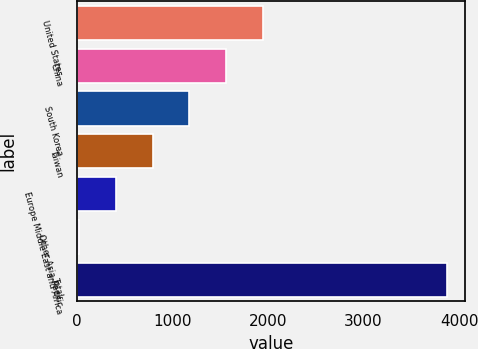<chart> <loc_0><loc_0><loc_500><loc_500><bar_chart><fcel>United States<fcel>China<fcel>South Korea<fcel>Taiwan<fcel>Europe Middle East and Africa<fcel>Other Asia-Pacific<fcel>Total<nl><fcel>1946.2<fcel>1560.76<fcel>1176.22<fcel>791.68<fcel>407.14<fcel>22.6<fcel>3868<nl></chart> 